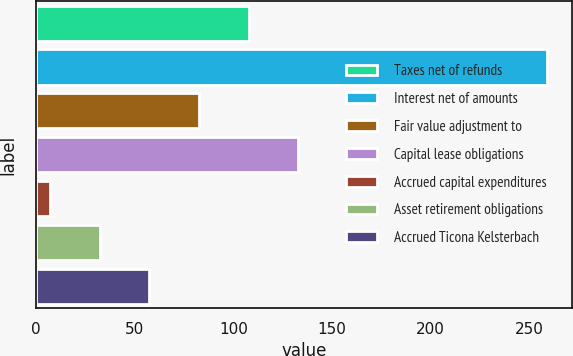<chart> <loc_0><loc_0><loc_500><loc_500><bar_chart><fcel>Taxes net of refunds<fcel>Interest net of amounts<fcel>Fair value adjustment to<fcel>Capital lease obligations<fcel>Accrued capital expenditures<fcel>Asset retirement obligations<fcel>Accrued Ticona Kelsterbach<nl><fcel>107.8<fcel>259<fcel>82.6<fcel>133<fcel>7<fcel>32.2<fcel>57.4<nl></chart> 